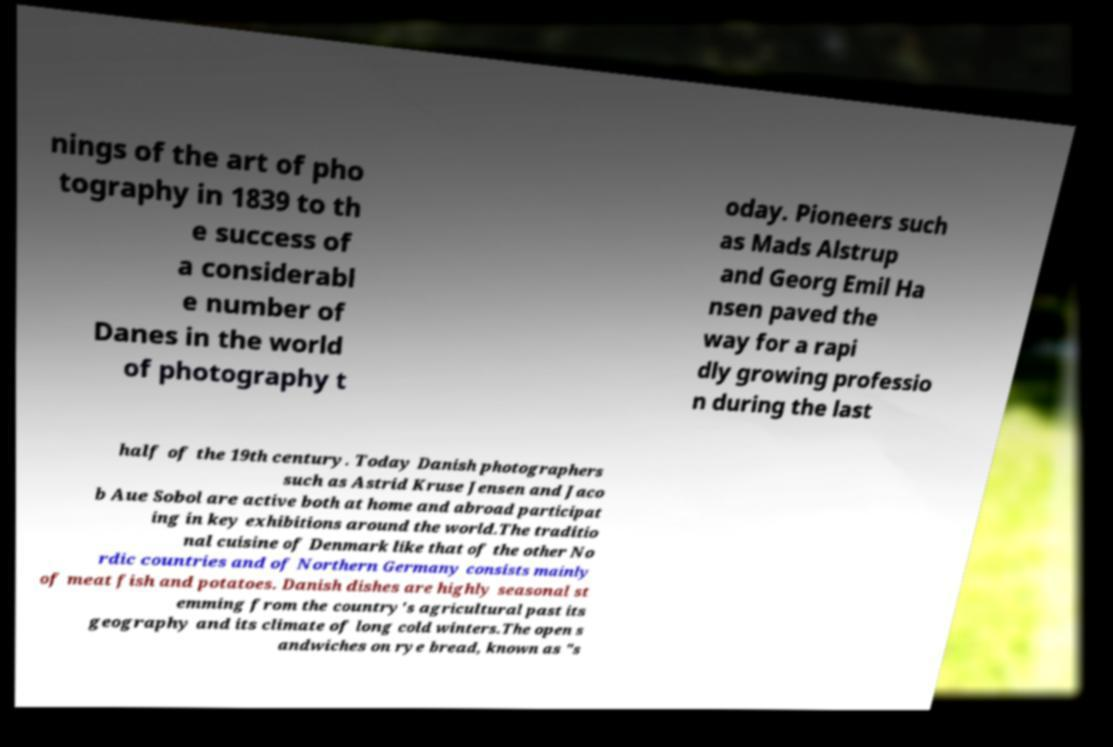There's text embedded in this image that I need extracted. Can you transcribe it verbatim? nings of the art of pho tography in 1839 to th e success of a considerabl e number of Danes in the world of photography t oday. Pioneers such as Mads Alstrup and Georg Emil Ha nsen paved the way for a rapi dly growing professio n during the last half of the 19th century. Today Danish photographers such as Astrid Kruse Jensen and Jaco b Aue Sobol are active both at home and abroad participat ing in key exhibitions around the world.The traditio nal cuisine of Denmark like that of the other No rdic countries and of Northern Germany consists mainly of meat fish and potatoes. Danish dishes are highly seasonal st emming from the country's agricultural past its geography and its climate of long cold winters.The open s andwiches on rye bread, known as "s 